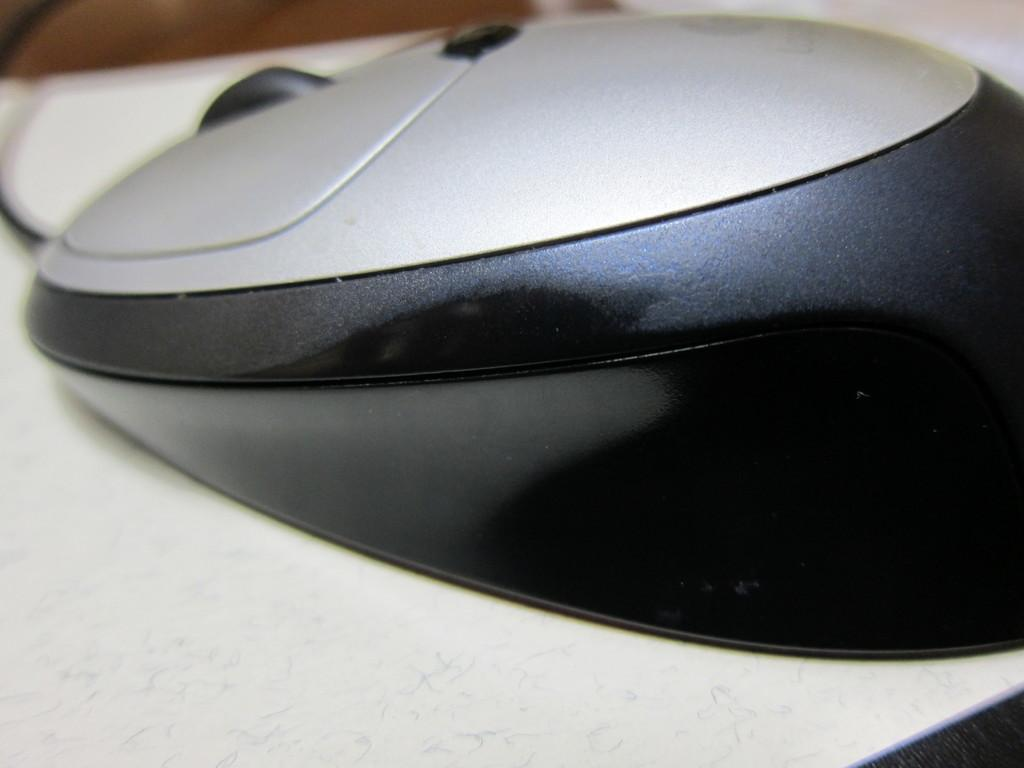What type of animal is present in the image? There is a mouse in the image. Where is the mouse located in the image? The mouse is on an object. What is the woman's reaction to the quarter in the image? There is no woman or quarter present in the image; it only features a mouse on an object. 